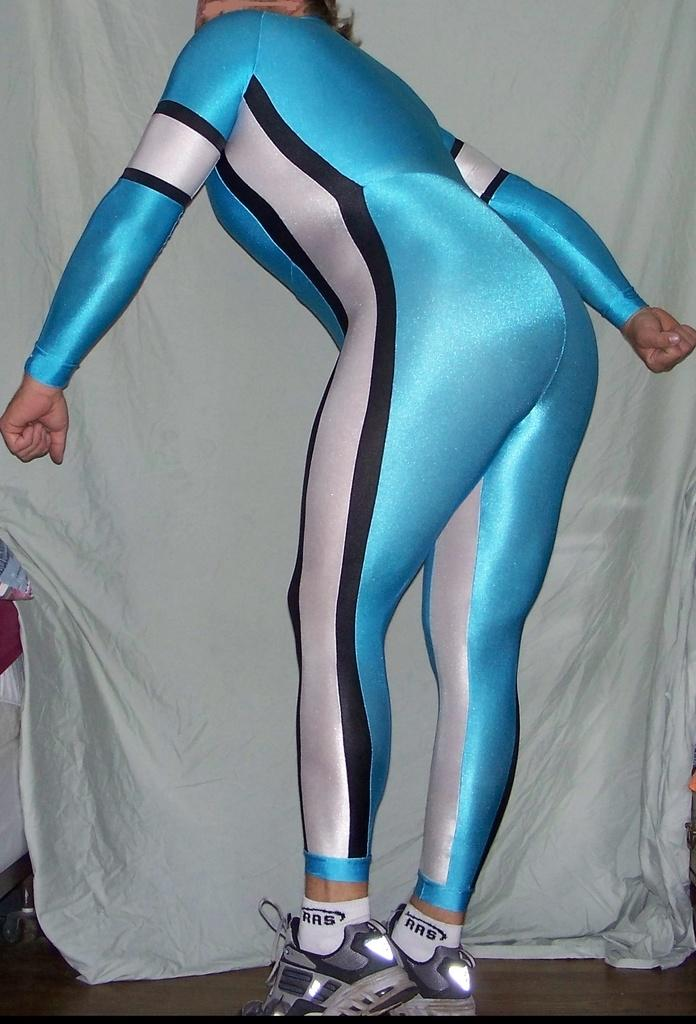Provide a one-sentence caption for the provided image. The skater has white socks on from the company RRB. 